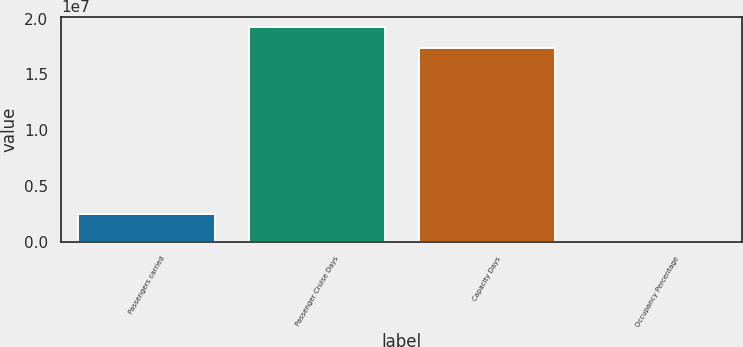Convert chart. <chart><loc_0><loc_0><loc_500><loc_500><bar_chart><fcel>Passengers carried<fcel>Passenger Cruise Days<fcel>Capacity Days<fcel>Occupancy Percentage<nl><fcel>2.51932e+06<fcel>1.92157e+07<fcel>1.73634e+07<fcel>106.7<nl></chart> 